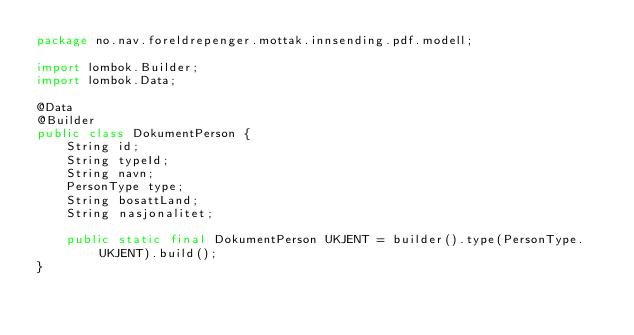<code> <loc_0><loc_0><loc_500><loc_500><_Java_>package no.nav.foreldrepenger.mottak.innsending.pdf.modell;

import lombok.Builder;
import lombok.Data;

@Data
@Builder
public class DokumentPerson {
    String id;
    String typeId;
    String navn;
    PersonType type;
    String bosattLand;
    String nasjonalitet;

    public static final DokumentPerson UKJENT = builder().type(PersonType.UKJENT).build();
}
</code> 